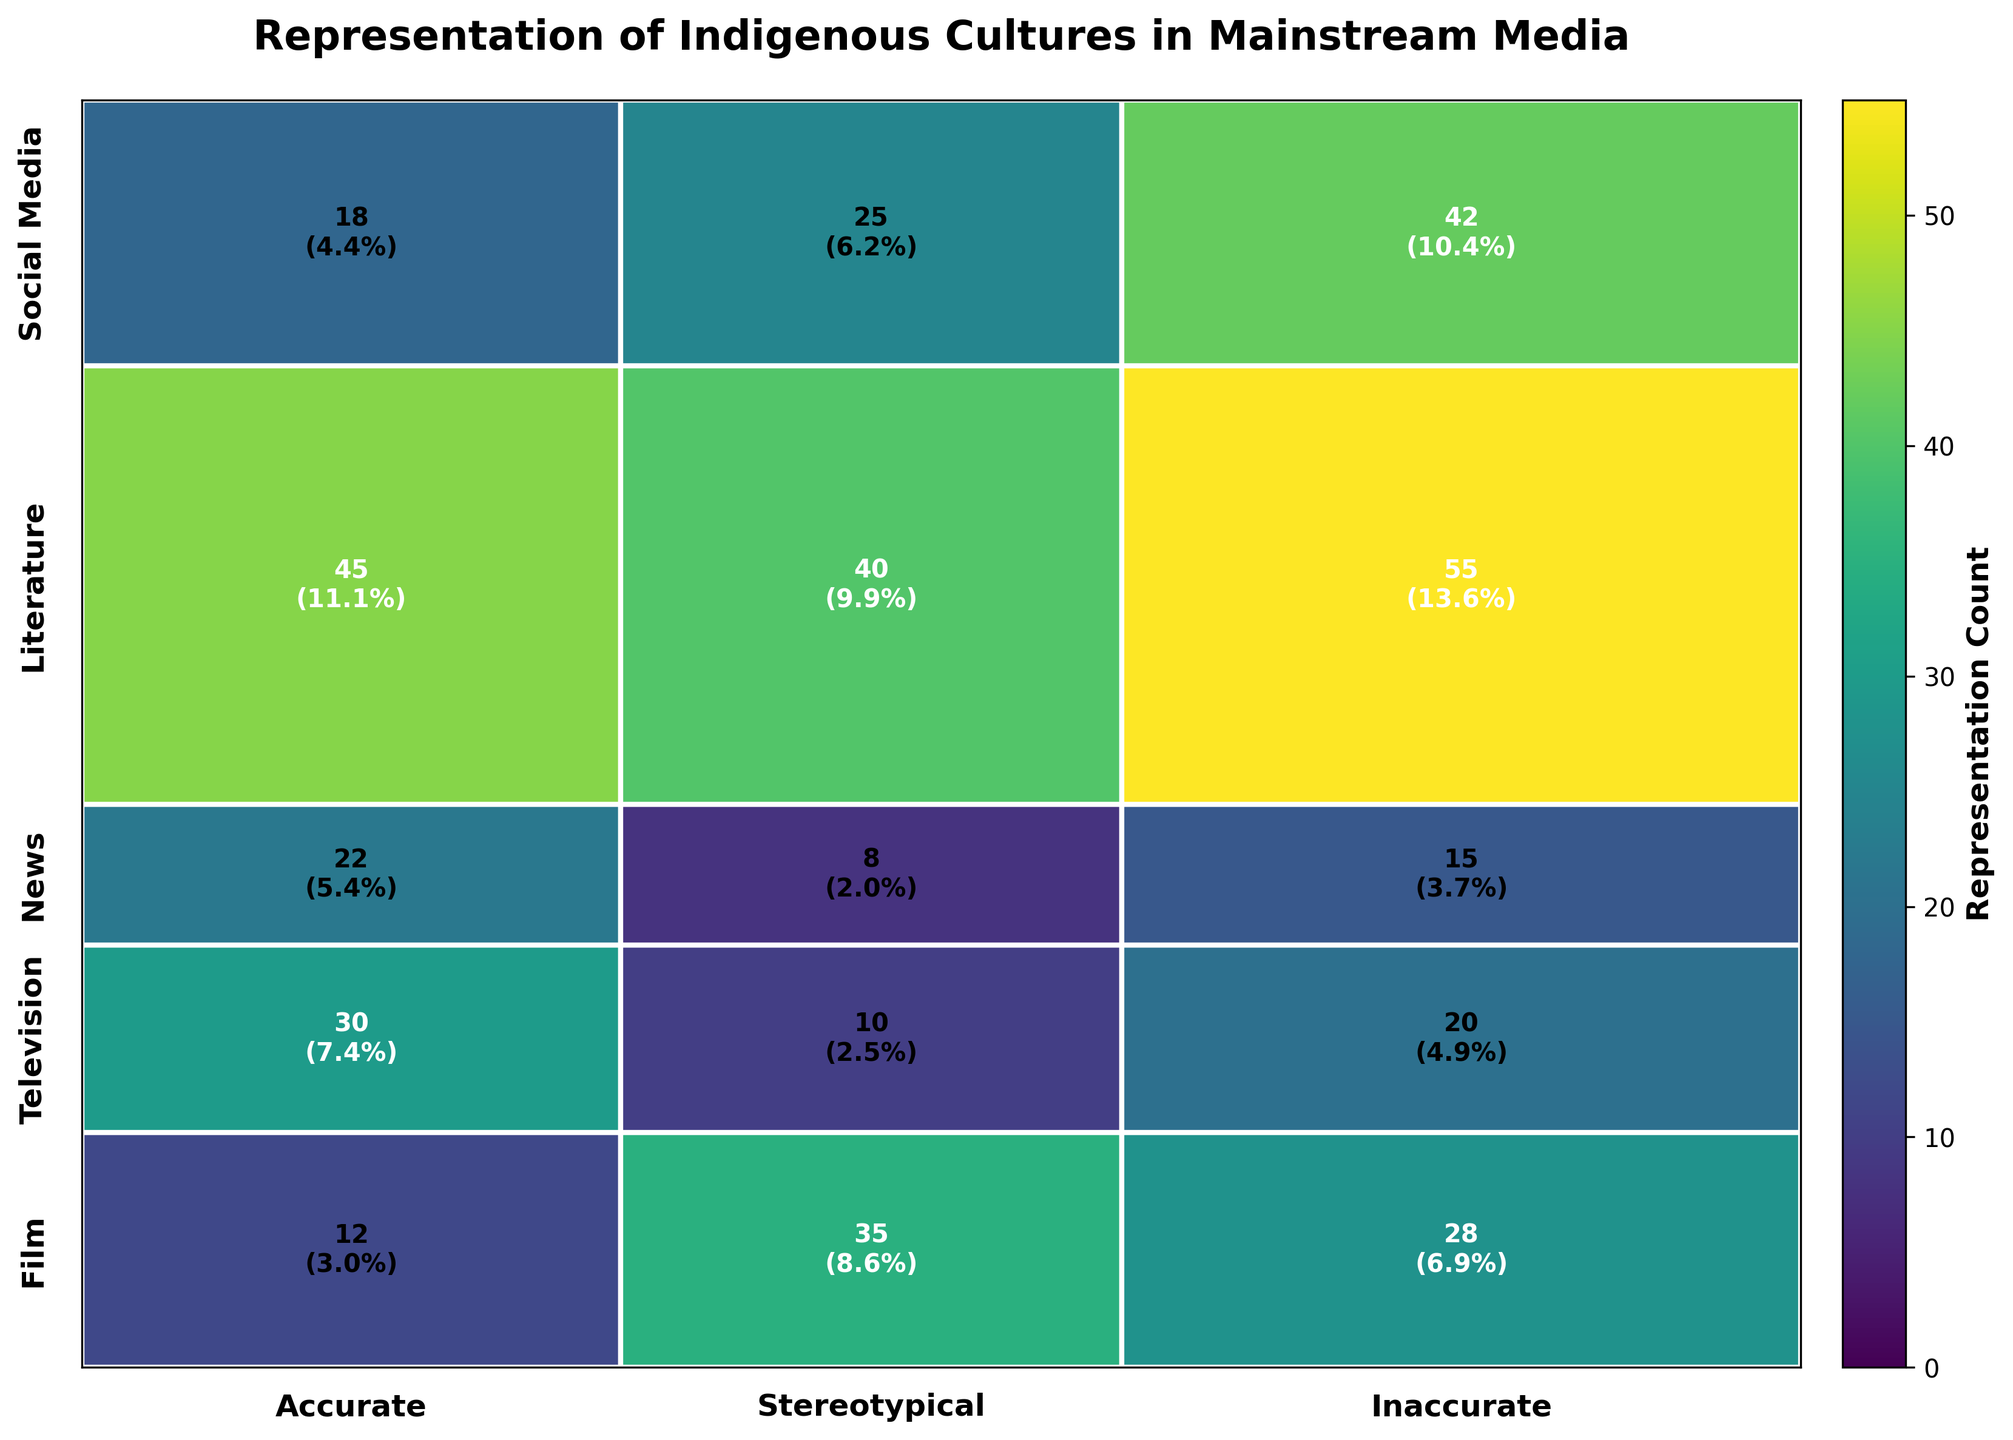What is the total count of accurate portrayals in all media types? We need to sum the counts of accurate portrayals across all media types. From the figure, the counts are: Film (12), Television (18), News (22), Literature (30), Social Media (45). Adding these together: 12+18+22+30+45 = 127
Answer: 127 Which media type has the highest count of stereotypical portrayals? Compare the counts of stereotypical portrayals across all media types. The counts are: Film (28), Television (42), News (15), Literature (20), Social Media (55). The highest count is in Social Media with 55.
Answer: Social Media How does the count of inaccurate portrayals in film compare to news? The count of inaccurate portrayals in Film is 35, while in News, it is 8. Comparing them, 35 is significantly higher than 8.
Answer: Film has a higher count What is the proportion of inaccurate portrayals in television relative to its total television portrayals? For Television: Inaccurate (25), Stereotypical (42), Accurate (18). Total = 25+42+18 = 85. The proportion of inaccurate portrayals: 25/85 ≈ 0.294 or 29.4%.
Answer: 29.4% What is the media type with the smallest total count of portrayals? Sum the counts of all portrayals for each media type. The total counts are: Film (75), Television (85), News (45), Literature (60), Social Media (140). The smallest total is for News with 45.
Answer: News How many more stereotypical portrayals are there than accurate portrayals in Social Media? Stereotypical portrayals in Social Media: 55, Accurate portrayals in Social Media: 45. Difference: 55 - 45 = 10.
Answer: 10 Which portrayal accuracy has the largest overall count in all media types combined? Sum the counts for all media types for each portrayal accuracy. Accurate (127), Stereotypical (160), Inaccurate (118). The largest overall count is for Stereotypical with 160.
Answer: Stereotypical What percentage of portrayals in Literature are accurate? For Literature: Accurate (30), Total (60). Proportion: 30/60 = 0.5 or 50%.
Answer: 50% Which media type has the lowest count of inaccurate portrayals? Compare the counts of inaccurate portrayals across all media types. The counts are: Film (35), Television (25), News (8), Literature (10), Social Media (40). The lowest count is in News with 8.
Answer: News What is the difference in the total representation count between Film and Social Media? Total representation counts are: Film (75), Social Media (140). Difference: 140 - 75 = 65.
Answer: 65 